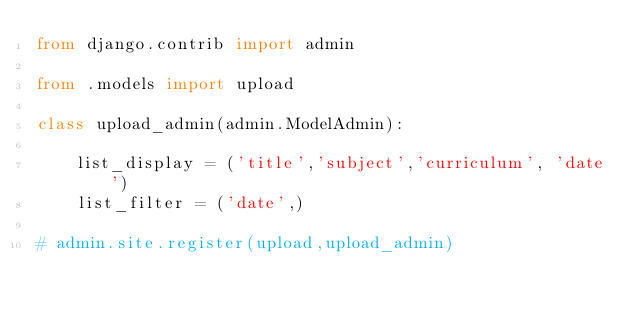<code> <loc_0><loc_0><loc_500><loc_500><_Python_>from django.contrib import admin

from .models import upload

class upload_admin(admin.ModelAdmin):
	
	list_display = ('title','subject','curriculum', 'date')
	list_filter = ('date',)

# admin.site.register(upload,upload_admin)
</code> 